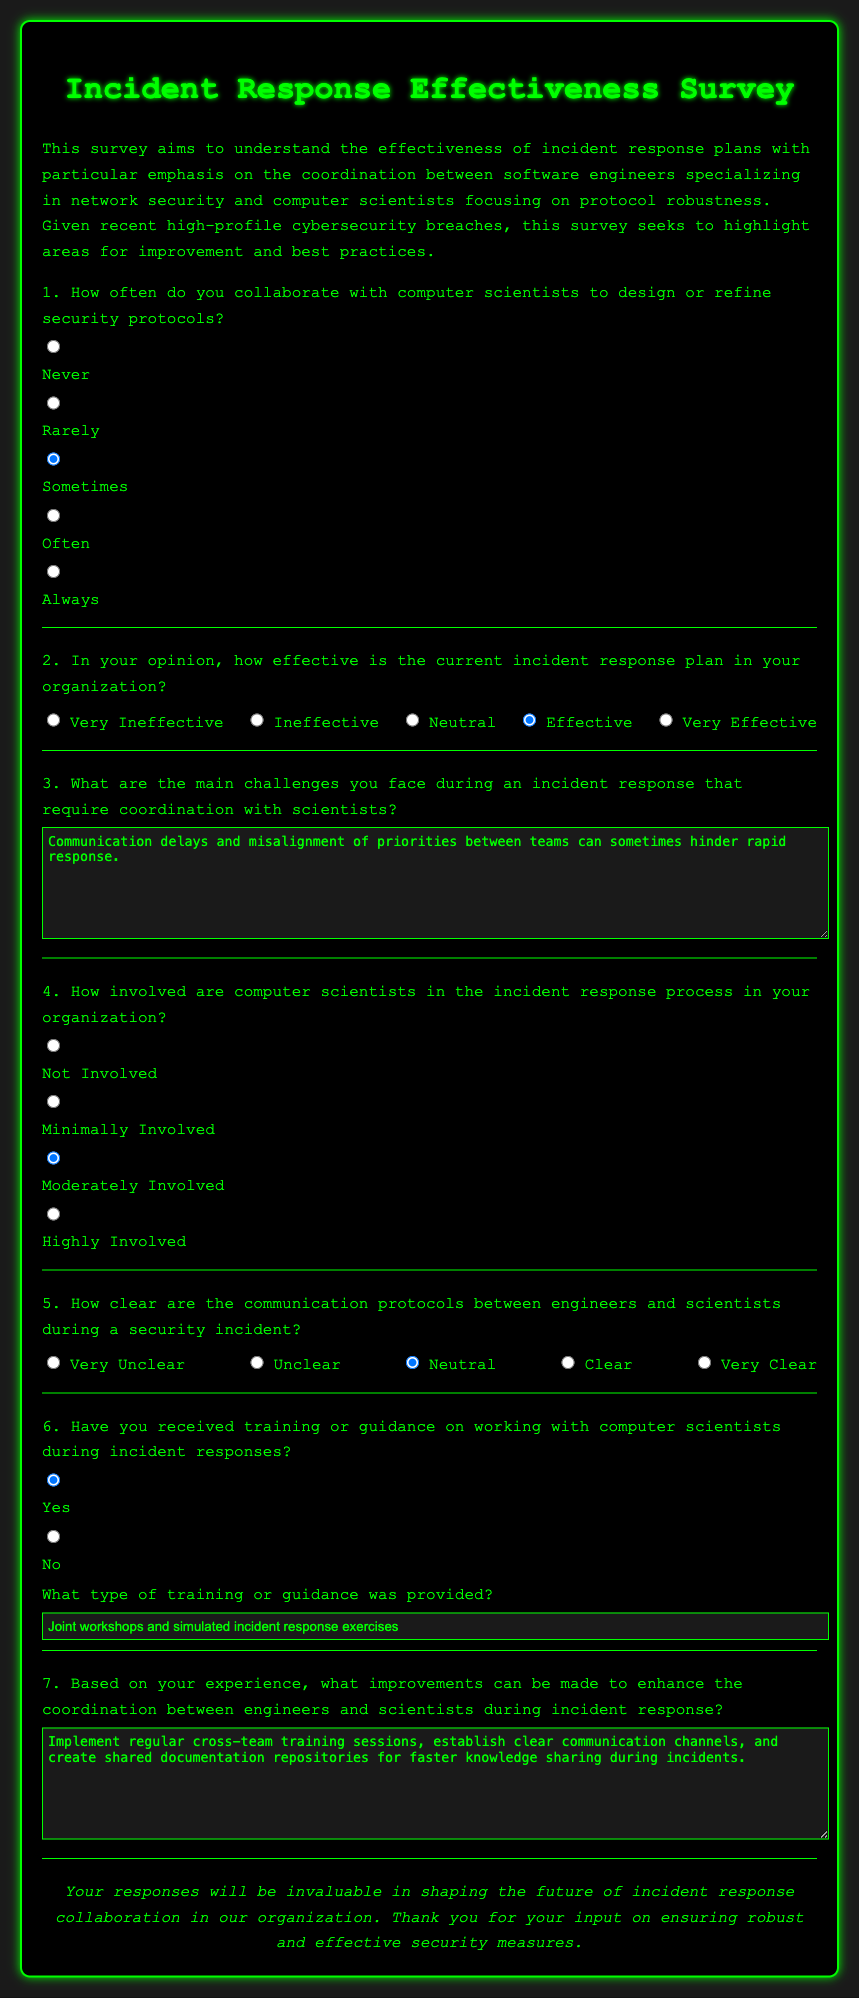1. How often do you collaborate with computer scientists? The frequency of collaboration between engineers and computer scientists is indicated in the survey as options from never to always.
Answer: Sometimes 2. What is the effectiveness rating of the current incident response plan? The survey asks for a rating from very ineffective to very effective, and the chosen response reflects the opinion on the plan's effectiveness.
Answer: Effective 3. What are the main challenges faced during an incident response? The respondent can describe the challenges in a text area, and an example response is given in the document.
Answer: Communication delays and misalignment of priorities 4. How involved are computer scientists in the incident response process? The document lists involvement levels ranging from not involved to highly involved, specifying one chosen level.
Answer: Moderately Involved 5. How clear are the communication protocols between engineers and scientists? This question presents a scale from very unclear to very clear, indicating the clarity of communication in security incidents.
Answer: Neutral 6. Have you received training or guidance on working with computer scientists? The survey allows for a simple yes or no response regarding training received on coordination during incident responses.
Answer: Yes 7. What type of training or guidance was provided? The respondent can specify the type of training in a text box, described in the survey.
Answer: Joint workshops and simulated incident response exercises 8. What improvements can enhance coordination during incident response? This question invites suggestions in a text box, which the respondent can provide based on their experience.
Answer: Implement regular cross-team training sessions 9. What is the primary objective of this survey? The document outlines the purpose of the survey in the introductory text.
Answer: Understand the effectiveness of incident response plans 10. What is the background color of the survey document? The document’s styling specifies a background color, which is relevant to design preferences.
Answer: Black 